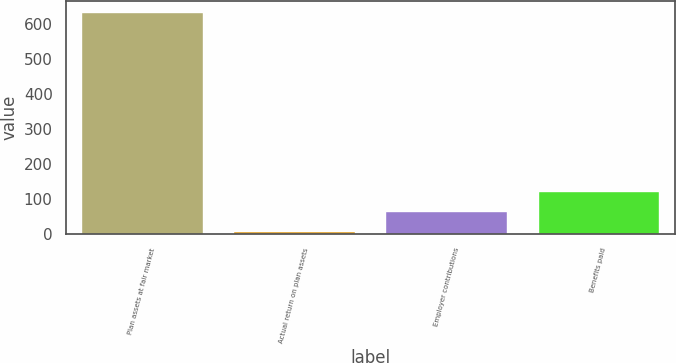Convert chart to OTSL. <chart><loc_0><loc_0><loc_500><loc_500><bar_chart><fcel>Plan assets at fair market<fcel>Actual return on plan assets<fcel>Employer contributions<fcel>Benefits paid<nl><fcel>632.73<fcel>7.5<fcel>65.33<fcel>123.16<nl></chart> 